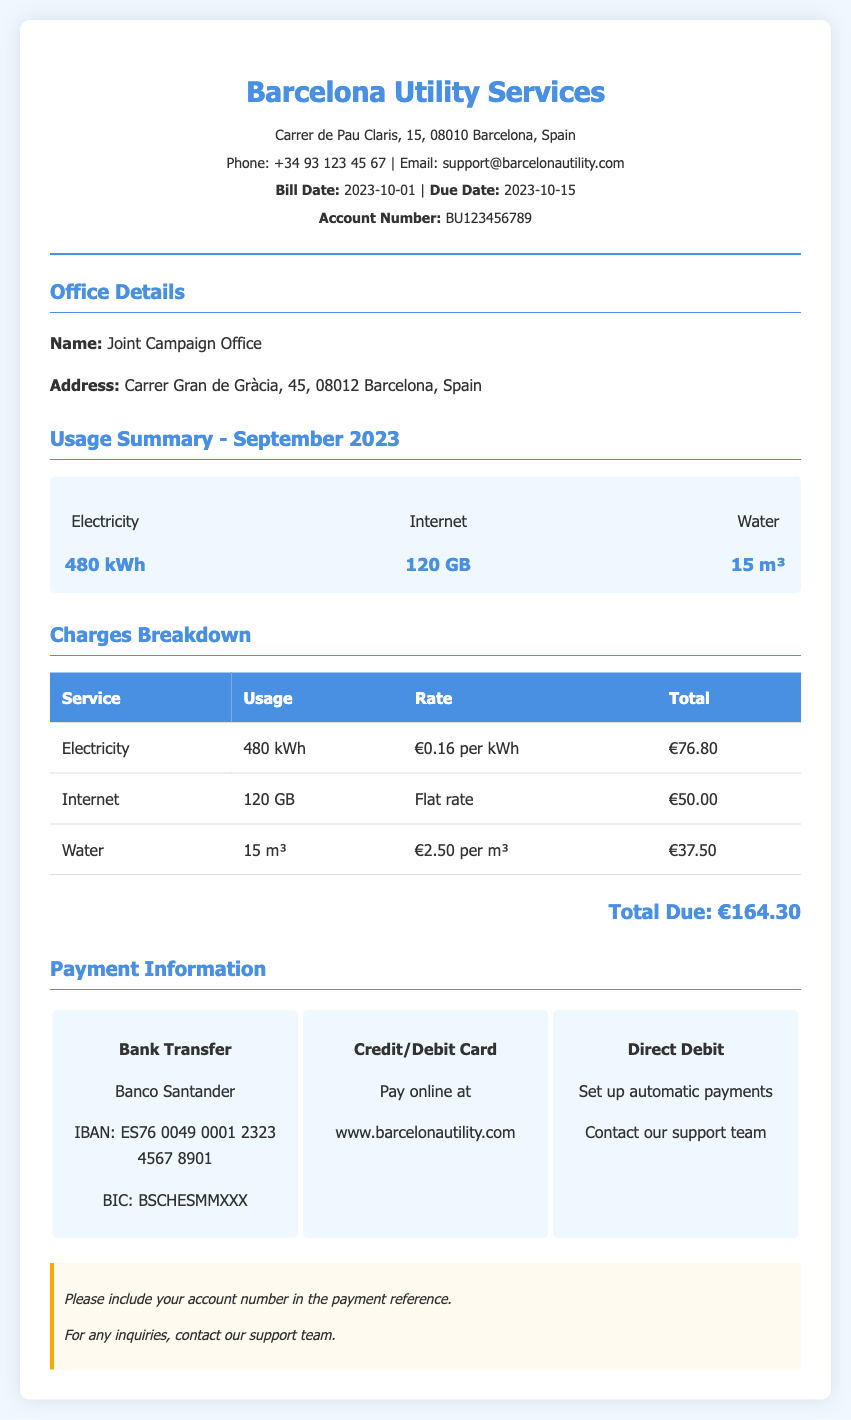what is the account number? The account number is listed in the header section of the document.
Answer: BU123456789 what is the usage of electricity? The electricity usage is summarized in the usage summary section of the document.
Answer: 480 kWh what is the total amount due? The total amount due is calculated from the charges breakdown for all services rendered.
Answer: €164.30 what is the rate for water? The rate for water is provided in the charges breakdown table of the document.
Answer: €2.50 per m³ which service had a flat rate charge? This information can be found in the charges breakdown table, which lists the types of charges for each service.
Answer: Internet what is the due date for the bill? The due date is specified in the header section of the document.
Answer: 2023-10-15 how many cubic meters of water were used? This detail is provided in the usage summary section of the document.
Answer: 15 m³ who is the utility service provider? This information is indicated in the header section of the document.
Answer: Barcelona Utility Services what payment method allows automatic payments? The payment methods section outlines different options for payment.
Answer: Direct Debit 